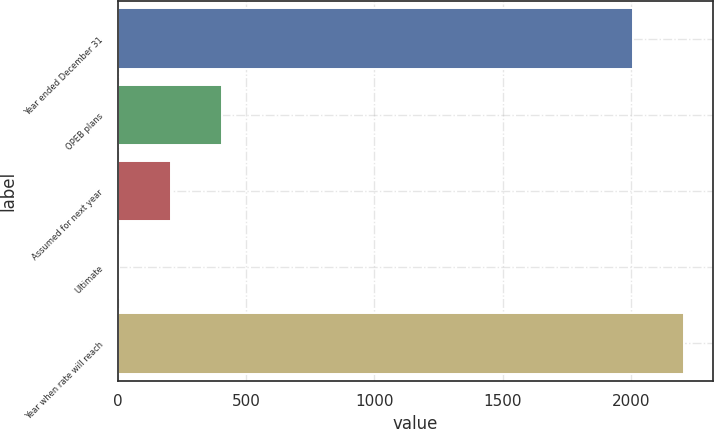Convert chart. <chart><loc_0><loc_0><loc_500><loc_500><bar_chart><fcel>Year ended December 31<fcel>OPEB plans<fcel>Assumed for next year<fcel>Ultimate<fcel>Year when rate will reach<nl><fcel>2008<fcel>405.2<fcel>204.6<fcel>4<fcel>2208.6<nl></chart> 